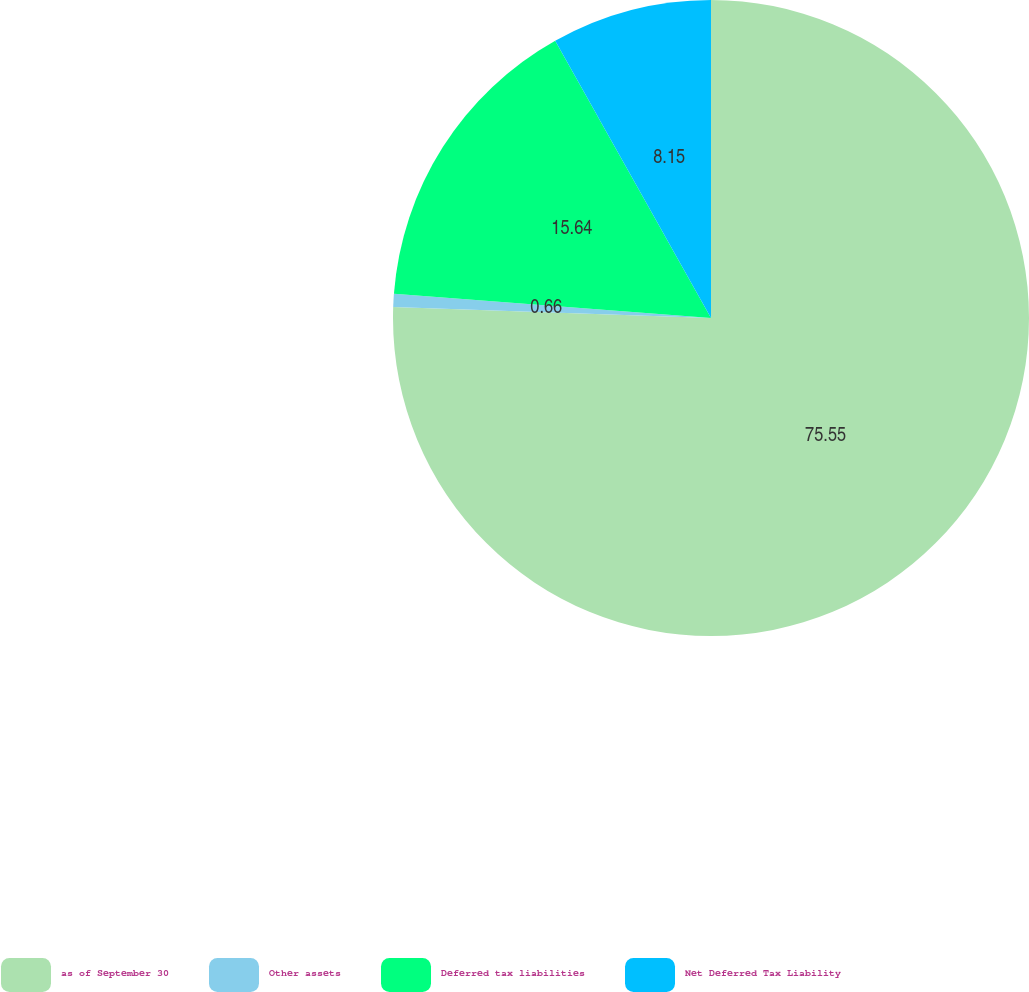Convert chart. <chart><loc_0><loc_0><loc_500><loc_500><pie_chart><fcel>as of September 30<fcel>Other assets<fcel>Deferred tax liabilities<fcel>Net Deferred Tax Liability<nl><fcel>75.55%<fcel>0.66%<fcel>15.64%<fcel>8.15%<nl></chart> 